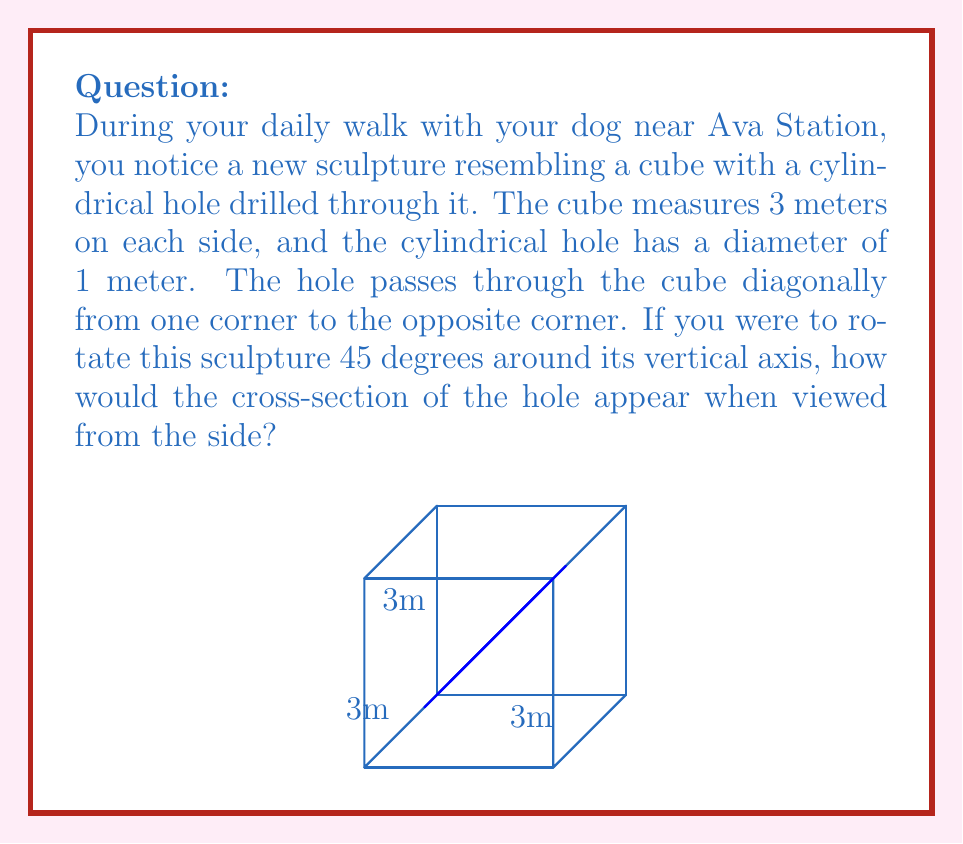Teach me how to tackle this problem. To solve this problem, let's break it down into steps:

1) First, we need to understand the initial configuration:
   - The cube has sides of 3 meters.
   - The cylindrical hole goes from one corner to the opposite corner diagonally.
   - The hole has a diameter of 1 meter.

2) The diagonal of the cube can be calculated using the formula:
   $$ d = a\sqrt{3} $$
   where $d$ is the diagonal and $a$ is the side length.
   So, $d = 3\sqrt{3} \approx 5.2$ meters.

3) When viewed from the side initially, the hole appears as an ellipse. This is because we're looking at a cylinder at an angle.

4) Now, when we rotate the cube 45 degrees around its vertical axis, we're essentially looking at the cube from a different angle, but the hole's orientation relative to the cube doesn't change.

5) After rotation, we're now looking at the hole from an angle that's halfway between its diagonal path and a face-on view. This means the ellipse will appear less elongated than in the initial view.

6) Mathematically, the shape we see is still an ellipse, but with different dimensions. The major axis of this ellipse will be the diameter of the hole (1 meter), while the minor axis will be:

   $$ 1 * \cos(45°) = \frac{1}{\sqrt{2}} \approx 0.707 \text{ meters} $$

7) Therefore, after rotation, the cross-section of the hole will appear as an ellipse with a major axis of 1 meter and a minor axis of approximately 0.707 meters.
Answer: An ellipse with major axis 1m and minor axis $\frac{1}{\sqrt{2}}$m 